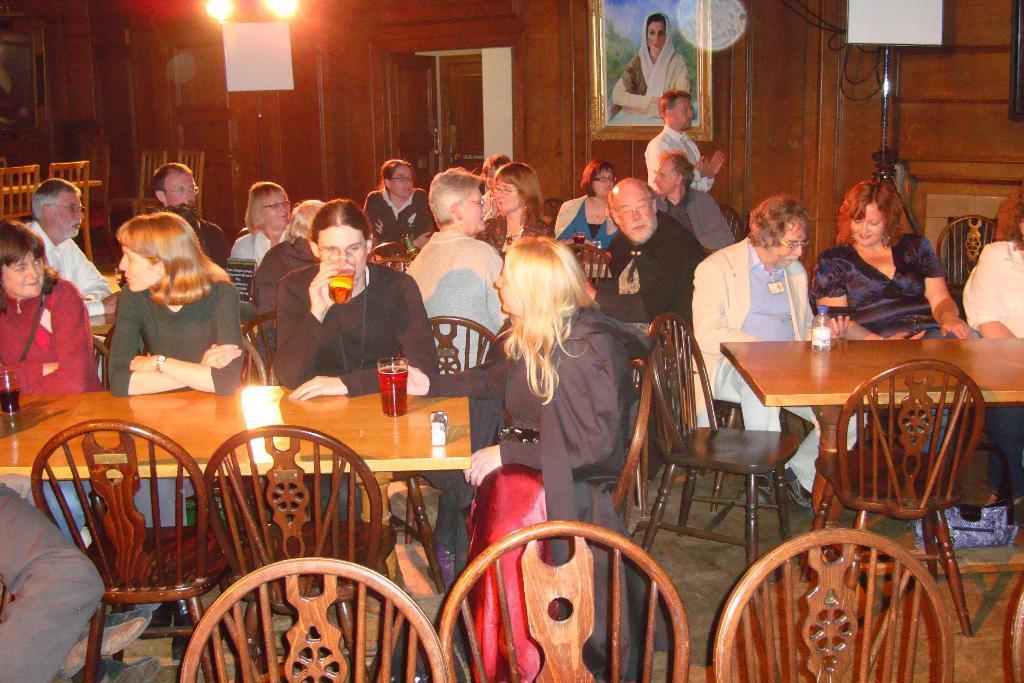In one or two sentences, can you explain what this image depicts? There is a room. There is a group of people. They are sitting on a chairs. In the corner side we have a person. He is standing. There is a table. There is a bottle,glass and light on a table. In the center we have a woman. She is holding a glass and she is drinking a juice. We can see in background cupboard,photo frame and lights. 